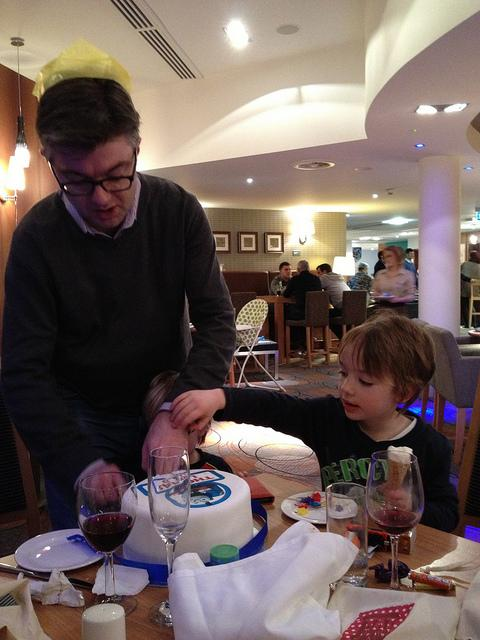Which person is likely celebrating a birthday? Please explain your reasoning. boy. The cake has a cartoon on it. 